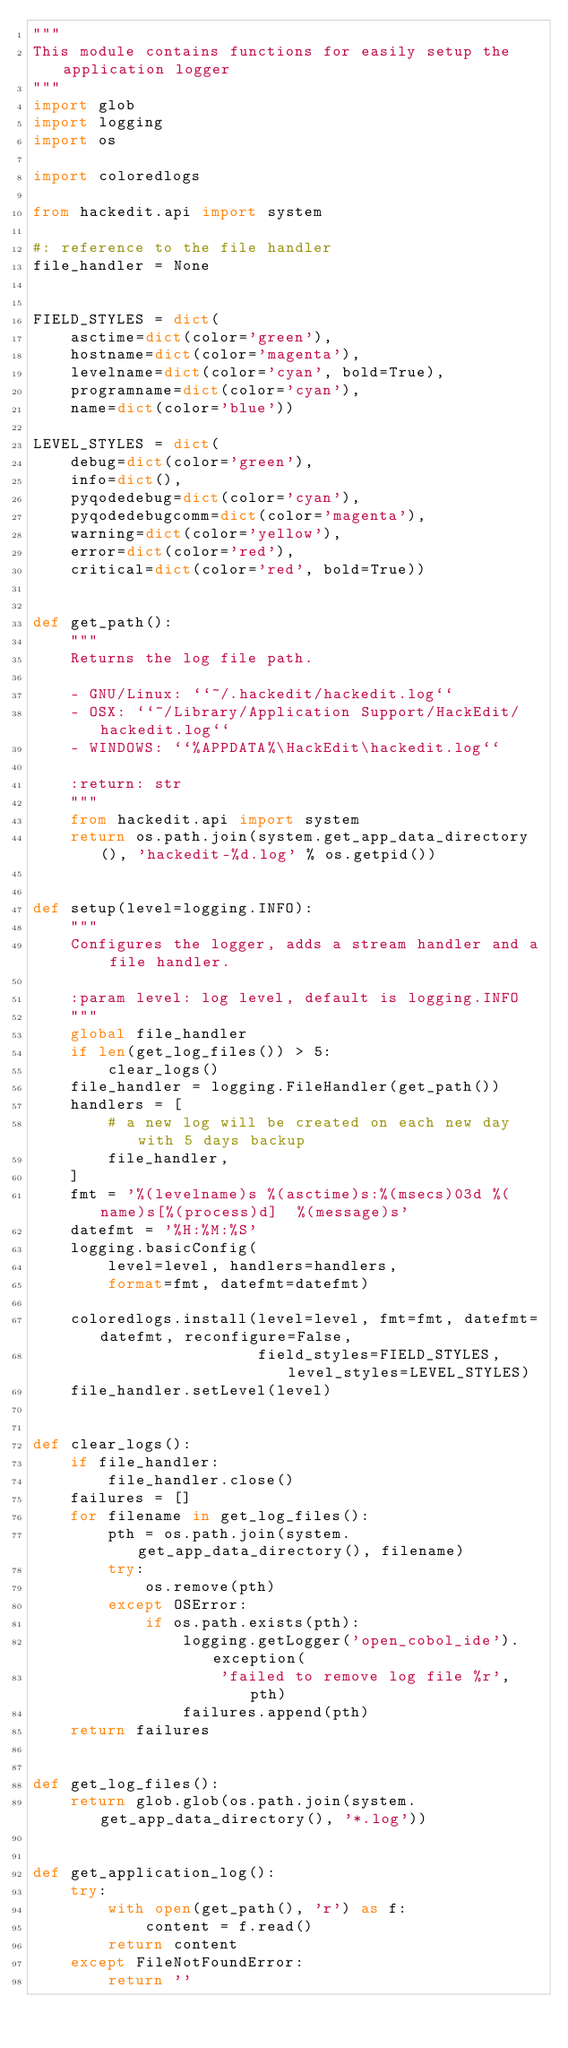Convert code to text. <code><loc_0><loc_0><loc_500><loc_500><_Python_>"""
This module contains functions for easily setup the application logger
"""
import glob
import logging
import os

import coloredlogs

from hackedit.api import system

#: reference to the file handler
file_handler = None


FIELD_STYLES = dict(
    asctime=dict(color='green'),
    hostname=dict(color='magenta'),
    levelname=dict(color='cyan', bold=True),
    programname=dict(color='cyan'),
    name=dict(color='blue'))

LEVEL_STYLES = dict(
    debug=dict(color='green'),
    info=dict(),
    pyqodedebug=dict(color='cyan'),
    pyqodedebugcomm=dict(color='magenta'),
    warning=dict(color='yellow'),
    error=dict(color='red'),
    critical=dict(color='red', bold=True))


def get_path():
    """
    Returns the log file path.

    - GNU/Linux: ``~/.hackedit/hackedit.log``
    - OSX: ``~/Library/Application Support/HackEdit/hackedit.log``
    - WINDOWS: ``%APPDATA%\HackEdit\hackedit.log``

    :return: str
    """
    from hackedit.api import system
    return os.path.join(system.get_app_data_directory(), 'hackedit-%d.log' % os.getpid())


def setup(level=logging.INFO):
    """
    Configures the logger, adds a stream handler and a file handler.

    :param level: log level, default is logging.INFO
    """
    global file_handler
    if len(get_log_files()) > 5:
        clear_logs()
    file_handler = logging.FileHandler(get_path())
    handlers = [
        # a new log will be created on each new day with 5 days backup
        file_handler,
    ]
    fmt = '%(levelname)s %(asctime)s:%(msecs)03d %(name)s[%(process)d]  %(message)s'
    datefmt = '%H:%M:%S'
    logging.basicConfig(
        level=level, handlers=handlers,
        format=fmt, datefmt=datefmt)

    coloredlogs.install(level=level, fmt=fmt, datefmt=datefmt, reconfigure=False,
                        field_styles=FIELD_STYLES, level_styles=LEVEL_STYLES)
    file_handler.setLevel(level)


def clear_logs():
    if file_handler:
        file_handler.close()
    failures = []
    for filename in get_log_files():
        pth = os.path.join(system.get_app_data_directory(), filename)
        try:
            os.remove(pth)
        except OSError:
            if os.path.exists(pth):
                logging.getLogger('open_cobol_ide').exception(
                    'failed to remove log file %r', pth)
                failures.append(pth)
    return failures


def get_log_files():
    return glob.glob(os.path.join(system.get_app_data_directory(), '*.log'))


def get_application_log():
    try:
        with open(get_path(), 'r') as f:
            content = f.read()
        return content
    except FileNotFoundError:
        return ''
</code> 